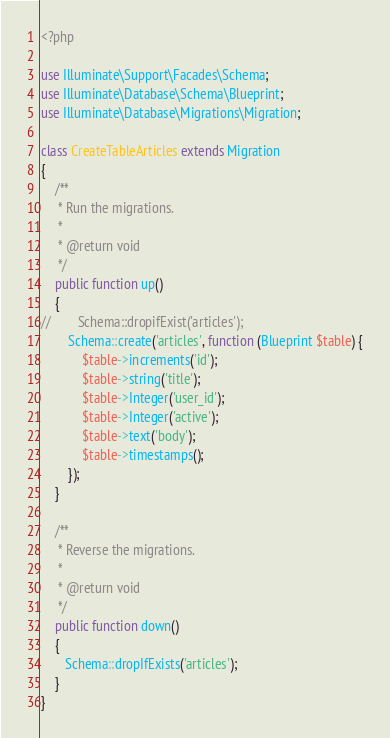Convert code to text. <code><loc_0><loc_0><loc_500><loc_500><_PHP_><?php

use Illuminate\Support\Facades\Schema;
use Illuminate\Database\Schema\Blueprint;
use Illuminate\Database\Migrations\Migration;

class CreateTableArticles extends Migration
{
    /**
     * Run the migrations.
     *
     * @return void
     */
    public function up()
    {
//        Schema::dropifExist('articles');
        Schema::create('articles', function (Blueprint $table) {
            $table->increments('id');
            $table->string('title');
            $table->Integer('user_id');
            $table->Integer('active');
            $table->text('body');
            $table->timestamps();
        });
    }

    /**
     * Reverse the migrations.
     *
     * @return void
     */
    public function down()
    {
       Schema::dropIfExists('articles');
    }
}
</code> 